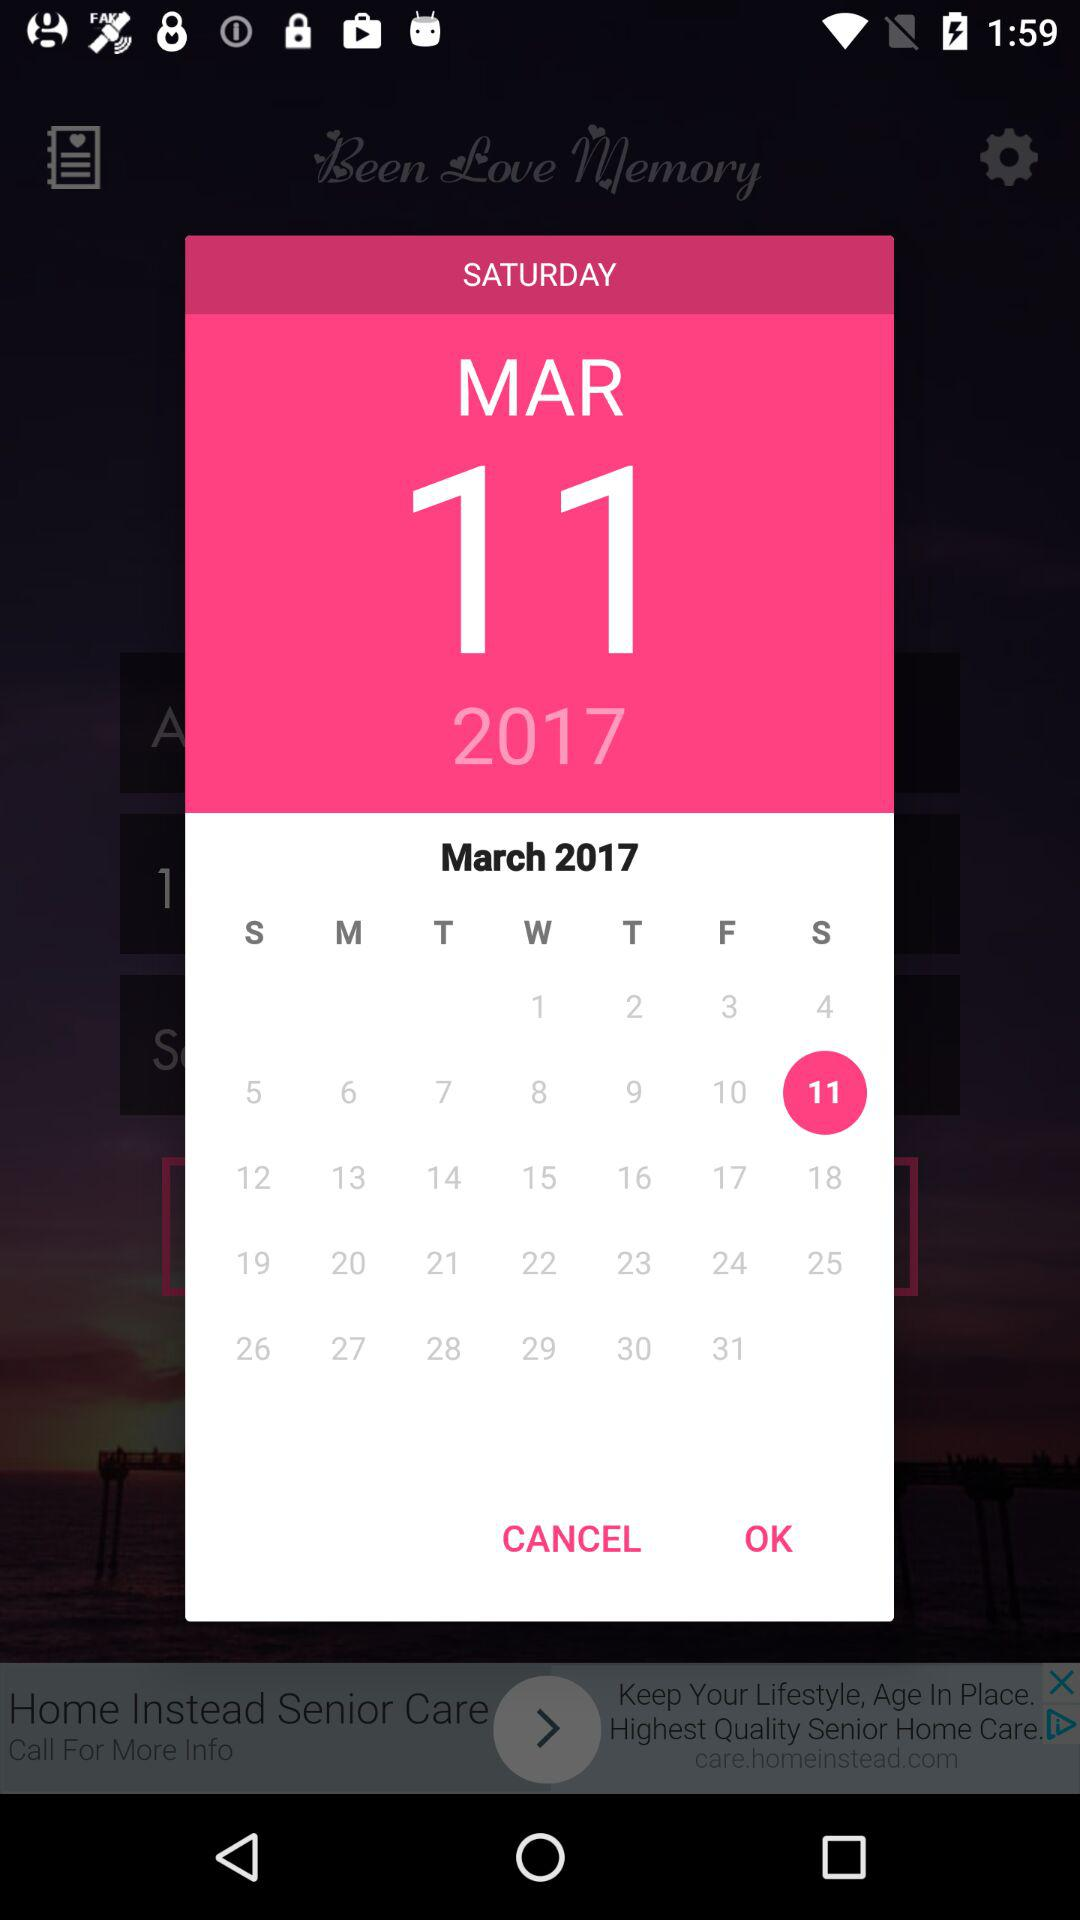What is the selected date? The selected date is Saturday, March 11, 2017. 